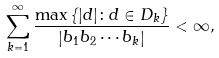Convert formula to latex. <formula><loc_0><loc_0><loc_500><loc_500>\sum _ { k = 1 } ^ { \infty } \frac { \max \left \{ | d | \colon d \in D _ { k } \right \} } { \left | b _ { 1 } b _ { 2 } \cdots b _ { k } \right | } < \infty ,</formula> 